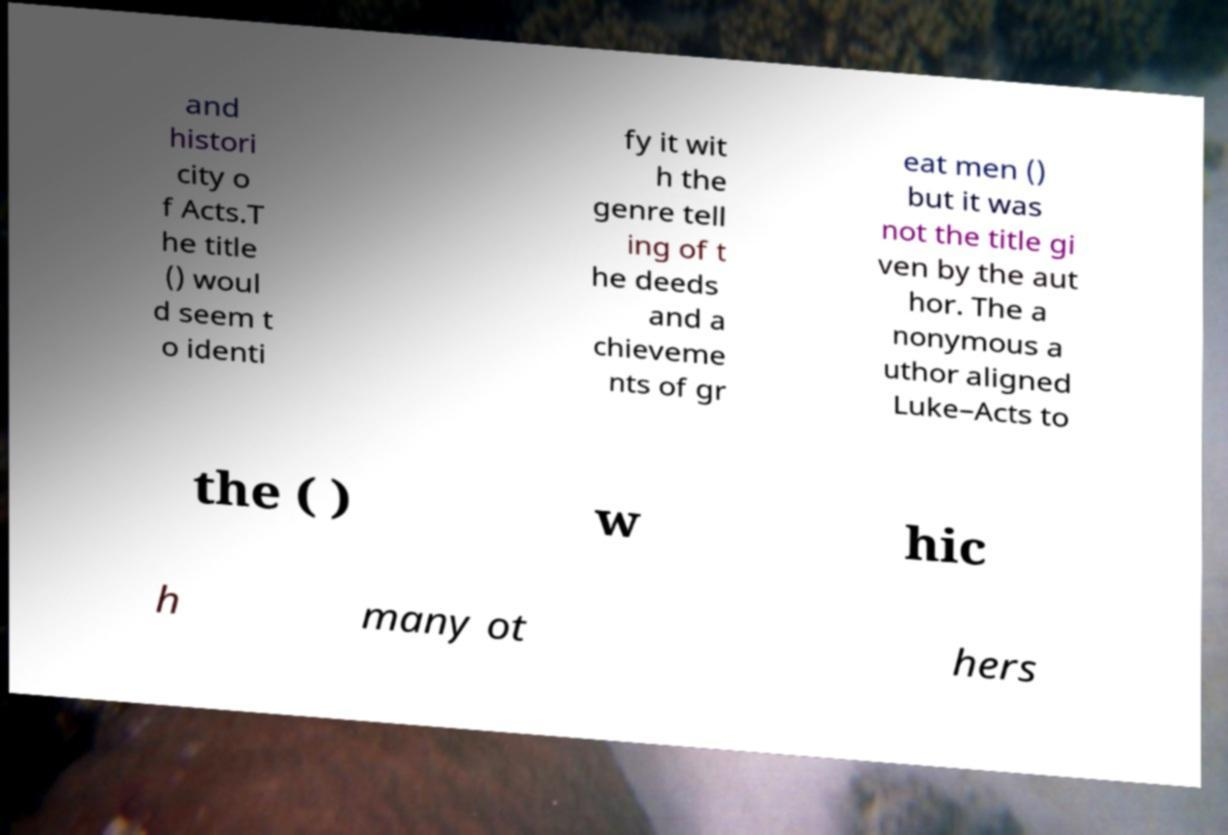Please identify and transcribe the text found in this image. and histori city o f Acts.T he title () woul d seem t o identi fy it wit h the genre tell ing of t he deeds and a chieveme nts of gr eat men () but it was not the title gi ven by the aut hor. The a nonymous a uthor aligned Luke–Acts to the ( ) w hic h many ot hers 